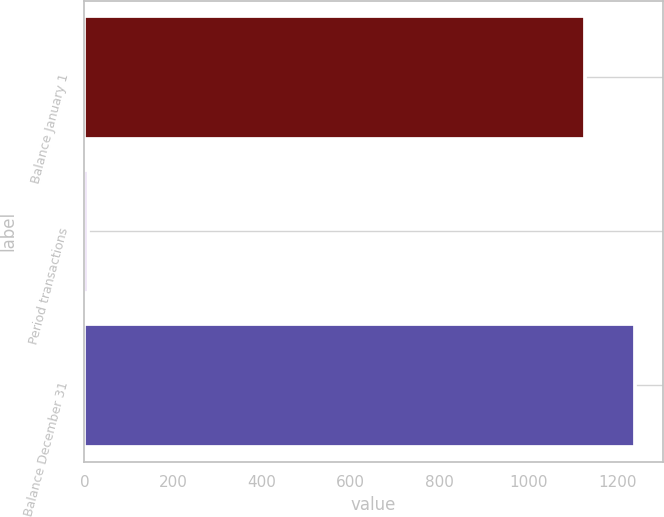<chart> <loc_0><loc_0><loc_500><loc_500><bar_chart><fcel>Balance January 1<fcel>Period transactions<fcel>Balance December 31<nl><fcel>1128<fcel>8<fcel>1240.8<nl></chart> 